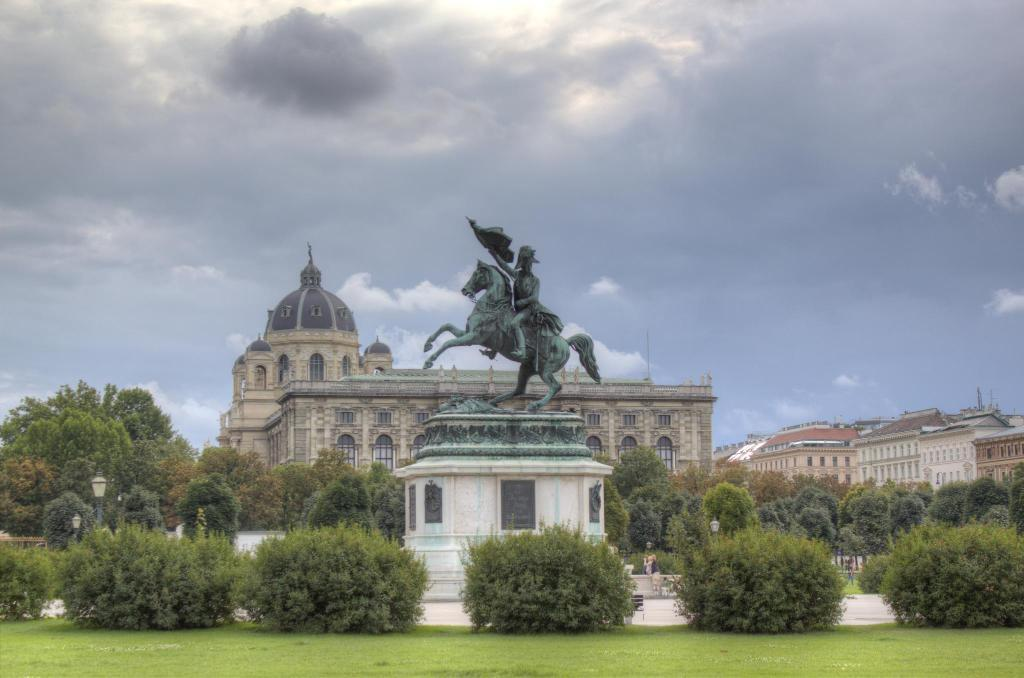What type of structure is present in the image? There is a building in the image. What is located in front of the building? There is a sculpture in front of the building. What type of vegetation can be seen in the image? There are trees visible in the image. How many boats are docked near the building in the image? There are no boats present in the image; it only features a building, a sculpture, and trees. 